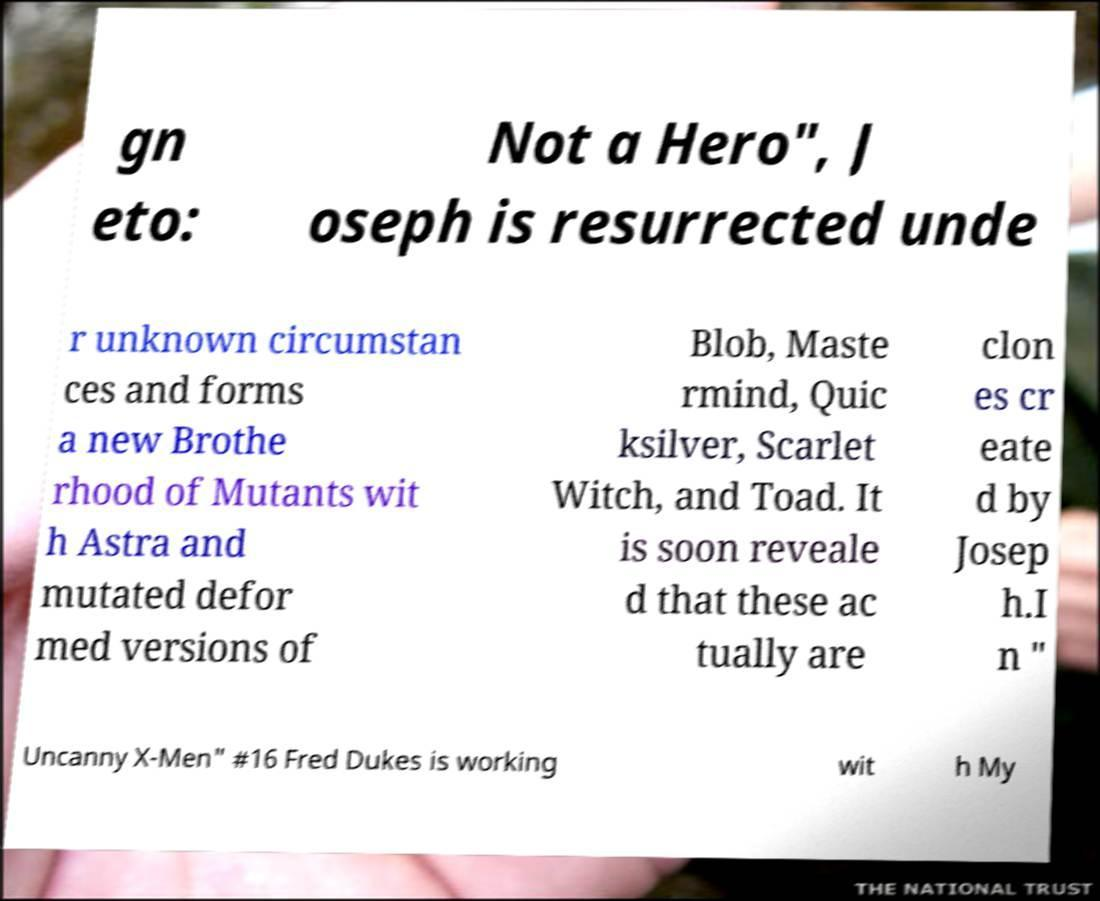Is this image discussing a specific storyline or event? Yes, the image references a storyline involving the resurrection of a character named Joseph and the creation of clones of various X-Men characters. This suggests a specific plot event or arc within the X-Men universe. 